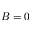Convert formula to latex. <formula><loc_0><loc_0><loc_500><loc_500>B = 0</formula> 